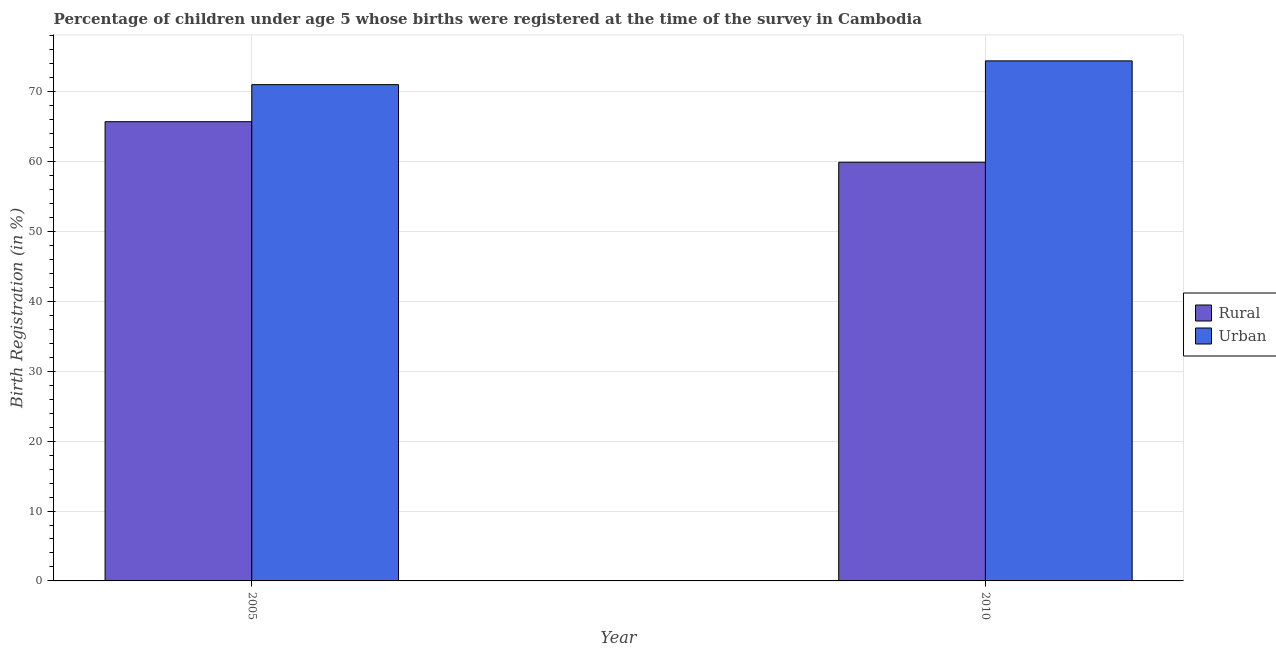How many different coloured bars are there?
Offer a very short reply. 2. How many bars are there on the 2nd tick from the left?
Your response must be concise. 2. How many bars are there on the 2nd tick from the right?
Provide a short and direct response. 2. In how many cases, is the number of bars for a given year not equal to the number of legend labels?
Keep it short and to the point. 0. What is the urban birth registration in 2010?
Make the answer very short. 74.4. Across all years, what is the maximum urban birth registration?
Your answer should be very brief. 74.4. What is the total urban birth registration in the graph?
Your answer should be very brief. 145.4. What is the difference between the rural birth registration in 2005 and that in 2010?
Offer a very short reply. 5.8. What is the difference between the urban birth registration in 2005 and the rural birth registration in 2010?
Provide a short and direct response. -3.4. What is the average rural birth registration per year?
Make the answer very short. 62.8. What is the ratio of the urban birth registration in 2005 to that in 2010?
Your answer should be compact. 0.95. What does the 1st bar from the left in 2010 represents?
Make the answer very short. Rural. What does the 1st bar from the right in 2005 represents?
Ensure brevity in your answer.  Urban. Are all the bars in the graph horizontal?
Your response must be concise. No. Are the values on the major ticks of Y-axis written in scientific E-notation?
Ensure brevity in your answer.  No. Does the graph contain any zero values?
Ensure brevity in your answer.  No. Does the graph contain grids?
Your answer should be compact. Yes. What is the title of the graph?
Your response must be concise. Percentage of children under age 5 whose births were registered at the time of the survey in Cambodia. Does "Urban" appear as one of the legend labels in the graph?
Your answer should be compact. Yes. What is the label or title of the Y-axis?
Give a very brief answer. Birth Registration (in %). What is the Birth Registration (in %) of Rural in 2005?
Offer a terse response. 65.7. What is the Birth Registration (in %) in Rural in 2010?
Give a very brief answer. 59.9. What is the Birth Registration (in %) in Urban in 2010?
Your response must be concise. 74.4. Across all years, what is the maximum Birth Registration (in %) in Rural?
Your answer should be very brief. 65.7. Across all years, what is the maximum Birth Registration (in %) of Urban?
Ensure brevity in your answer.  74.4. Across all years, what is the minimum Birth Registration (in %) in Rural?
Keep it short and to the point. 59.9. What is the total Birth Registration (in %) in Rural in the graph?
Provide a short and direct response. 125.6. What is the total Birth Registration (in %) of Urban in the graph?
Your answer should be compact. 145.4. What is the difference between the Birth Registration (in %) of Rural in 2005 and the Birth Registration (in %) of Urban in 2010?
Offer a very short reply. -8.7. What is the average Birth Registration (in %) in Rural per year?
Offer a very short reply. 62.8. What is the average Birth Registration (in %) in Urban per year?
Your response must be concise. 72.7. In the year 2005, what is the difference between the Birth Registration (in %) in Rural and Birth Registration (in %) in Urban?
Your response must be concise. -5.3. In the year 2010, what is the difference between the Birth Registration (in %) of Rural and Birth Registration (in %) of Urban?
Offer a very short reply. -14.5. What is the ratio of the Birth Registration (in %) in Rural in 2005 to that in 2010?
Provide a succinct answer. 1.1. What is the ratio of the Birth Registration (in %) in Urban in 2005 to that in 2010?
Your answer should be very brief. 0.95. What is the difference between the highest and the second highest Birth Registration (in %) in Rural?
Make the answer very short. 5.8. 